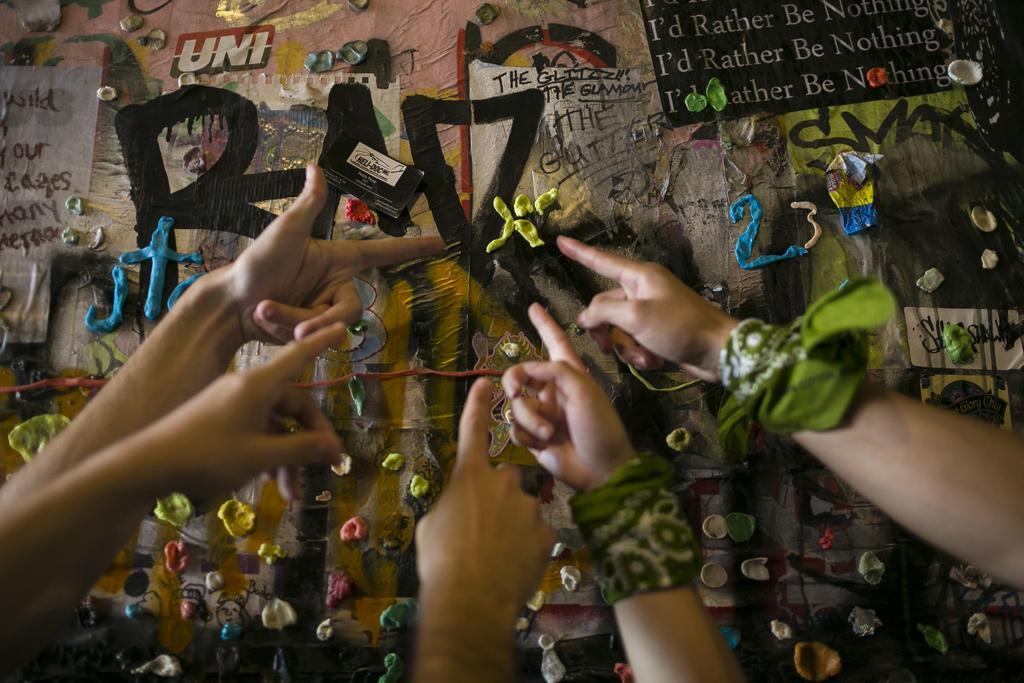How would you summarize this image in a sentence or two? In this picture there are hands in the center of the image, there is clay on the poster in the image. 